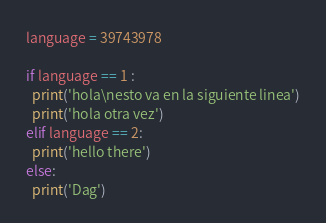Convert code to text. <code><loc_0><loc_0><loc_500><loc_500><_Python_>language = 39743978

if language == 1 :
  print('hola\nesto va en la siguiente linea')
  print('hola otra vez')
elif language == 2:
  print('hello there')
else:
  print('Dag')

</code> 